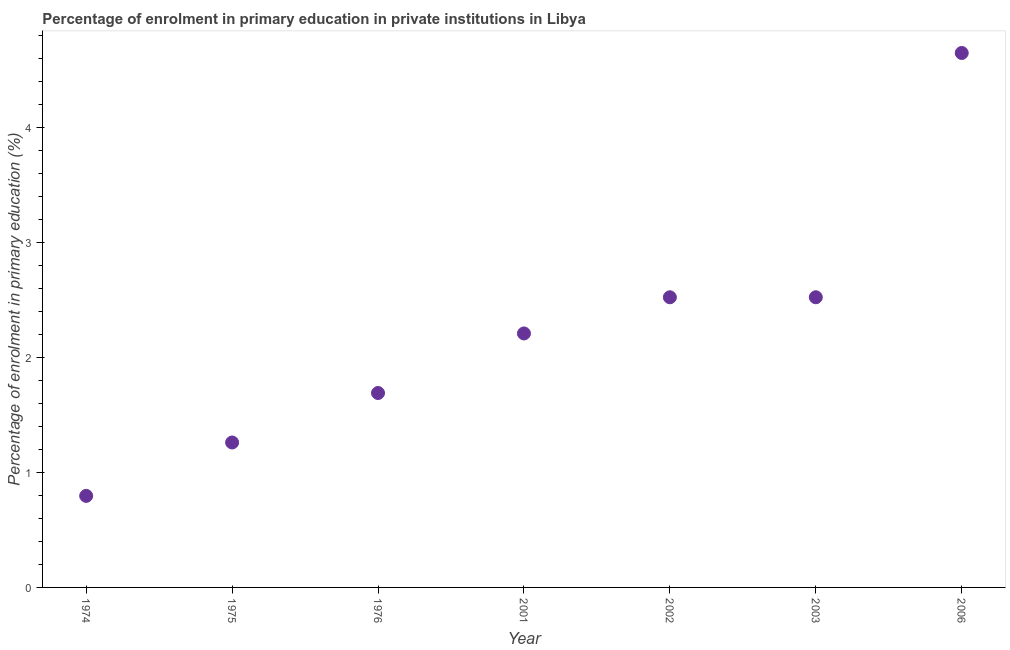What is the enrolment percentage in primary education in 2003?
Provide a succinct answer. 2.53. Across all years, what is the maximum enrolment percentage in primary education?
Ensure brevity in your answer.  4.65. Across all years, what is the minimum enrolment percentage in primary education?
Your answer should be compact. 0.8. In which year was the enrolment percentage in primary education minimum?
Your answer should be compact. 1974. What is the sum of the enrolment percentage in primary education?
Give a very brief answer. 15.67. What is the difference between the enrolment percentage in primary education in 1975 and 2001?
Your answer should be compact. -0.95. What is the average enrolment percentage in primary education per year?
Provide a short and direct response. 2.24. What is the median enrolment percentage in primary education?
Your response must be concise. 2.21. In how many years, is the enrolment percentage in primary education greater than 1.2 %?
Your answer should be very brief. 6. Do a majority of the years between 2006 and 1974 (inclusive) have enrolment percentage in primary education greater than 4.6 %?
Offer a very short reply. Yes. What is the ratio of the enrolment percentage in primary education in 1976 to that in 2001?
Keep it short and to the point. 0.77. What is the difference between the highest and the second highest enrolment percentage in primary education?
Your answer should be very brief. 2.13. What is the difference between the highest and the lowest enrolment percentage in primary education?
Your answer should be very brief. 3.86. How many dotlines are there?
Provide a succinct answer. 1. How many years are there in the graph?
Keep it short and to the point. 7. What is the difference between two consecutive major ticks on the Y-axis?
Offer a very short reply. 1. Are the values on the major ticks of Y-axis written in scientific E-notation?
Your response must be concise. No. Does the graph contain any zero values?
Make the answer very short. No. What is the title of the graph?
Give a very brief answer. Percentage of enrolment in primary education in private institutions in Libya. What is the label or title of the Y-axis?
Your answer should be compact. Percentage of enrolment in primary education (%). What is the Percentage of enrolment in primary education (%) in 1974?
Make the answer very short. 0.8. What is the Percentage of enrolment in primary education (%) in 1975?
Keep it short and to the point. 1.26. What is the Percentage of enrolment in primary education (%) in 1976?
Your answer should be very brief. 1.69. What is the Percentage of enrolment in primary education (%) in 2001?
Your response must be concise. 2.21. What is the Percentage of enrolment in primary education (%) in 2002?
Your response must be concise. 2.53. What is the Percentage of enrolment in primary education (%) in 2003?
Ensure brevity in your answer.  2.53. What is the Percentage of enrolment in primary education (%) in 2006?
Make the answer very short. 4.65. What is the difference between the Percentage of enrolment in primary education (%) in 1974 and 1975?
Give a very brief answer. -0.46. What is the difference between the Percentage of enrolment in primary education (%) in 1974 and 1976?
Offer a very short reply. -0.9. What is the difference between the Percentage of enrolment in primary education (%) in 1974 and 2001?
Provide a short and direct response. -1.41. What is the difference between the Percentage of enrolment in primary education (%) in 1974 and 2002?
Your answer should be compact. -1.73. What is the difference between the Percentage of enrolment in primary education (%) in 1974 and 2003?
Give a very brief answer. -1.73. What is the difference between the Percentage of enrolment in primary education (%) in 1974 and 2006?
Offer a very short reply. -3.86. What is the difference between the Percentage of enrolment in primary education (%) in 1975 and 1976?
Give a very brief answer. -0.43. What is the difference between the Percentage of enrolment in primary education (%) in 1975 and 2001?
Your response must be concise. -0.95. What is the difference between the Percentage of enrolment in primary education (%) in 1975 and 2002?
Give a very brief answer. -1.26. What is the difference between the Percentage of enrolment in primary education (%) in 1975 and 2003?
Give a very brief answer. -1.26. What is the difference between the Percentage of enrolment in primary education (%) in 1975 and 2006?
Provide a short and direct response. -3.39. What is the difference between the Percentage of enrolment in primary education (%) in 1976 and 2001?
Ensure brevity in your answer.  -0.52. What is the difference between the Percentage of enrolment in primary education (%) in 1976 and 2002?
Your answer should be very brief. -0.83. What is the difference between the Percentage of enrolment in primary education (%) in 1976 and 2003?
Offer a terse response. -0.83. What is the difference between the Percentage of enrolment in primary education (%) in 1976 and 2006?
Your answer should be very brief. -2.96. What is the difference between the Percentage of enrolment in primary education (%) in 2001 and 2002?
Keep it short and to the point. -0.32. What is the difference between the Percentage of enrolment in primary education (%) in 2001 and 2003?
Ensure brevity in your answer.  -0.32. What is the difference between the Percentage of enrolment in primary education (%) in 2001 and 2006?
Your response must be concise. -2.44. What is the difference between the Percentage of enrolment in primary education (%) in 2002 and 2003?
Keep it short and to the point. -4e-5. What is the difference between the Percentage of enrolment in primary education (%) in 2002 and 2006?
Your response must be concise. -2.13. What is the difference between the Percentage of enrolment in primary education (%) in 2003 and 2006?
Offer a very short reply. -2.13. What is the ratio of the Percentage of enrolment in primary education (%) in 1974 to that in 1975?
Your answer should be very brief. 0.63. What is the ratio of the Percentage of enrolment in primary education (%) in 1974 to that in 1976?
Ensure brevity in your answer.  0.47. What is the ratio of the Percentage of enrolment in primary education (%) in 1974 to that in 2001?
Offer a terse response. 0.36. What is the ratio of the Percentage of enrolment in primary education (%) in 1974 to that in 2002?
Your answer should be very brief. 0.32. What is the ratio of the Percentage of enrolment in primary education (%) in 1974 to that in 2003?
Provide a succinct answer. 0.32. What is the ratio of the Percentage of enrolment in primary education (%) in 1974 to that in 2006?
Your answer should be very brief. 0.17. What is the ratio of the Percentage of enrolment in primary education (%) in 1975 to that in 1976?
Make the answer very short. 0.75. What is the ratio of the Percentage of enrolment in primary education (%) in 1975 to that in 2001?
Make the answer very short. 0.57. What is the ratio of the Percentage of enrolment in primary education (%) in 1975 to that in 2006?
Your answer should be compact. 0.27. What is the ratio of the Percentage of enrolment in primary education (%) in 1976 to that in 2001?
Make the answer very short. 0.77. What is the ratio of the Percentage of enrolment in primary education (%) in 1976 to that in 2002?
Keep it short and to the point. 0.67. What is the ratio of the Percentage of enrolment in primary education (%) in 1976 to that in 2003?
Give a very brief answer. 0.67. What is the ratio of the Percentage of enrolment in primary education (%) in 1976 to that in 2006?
Offer a terse response. 0.36. What is the ratio of the Percentage of enrolment in primary education (%) in 2001 to that in 2003?
Make the answer very short. 0.88. What is the ratio of the Percentage of enrolment in primary education (%) in 2001 to that in 2006?
Your answer should be very brief. 0.47. What is the ratio of the Percentage of enrolment in primary education (%) in 2002 to that in 2006?
Your answer should be compact. 0.54. What is the ratio of the Percentage of enrolment in primary education (%) in 2003 to that in 2006?
Keep it short and to the point. 0.54. 